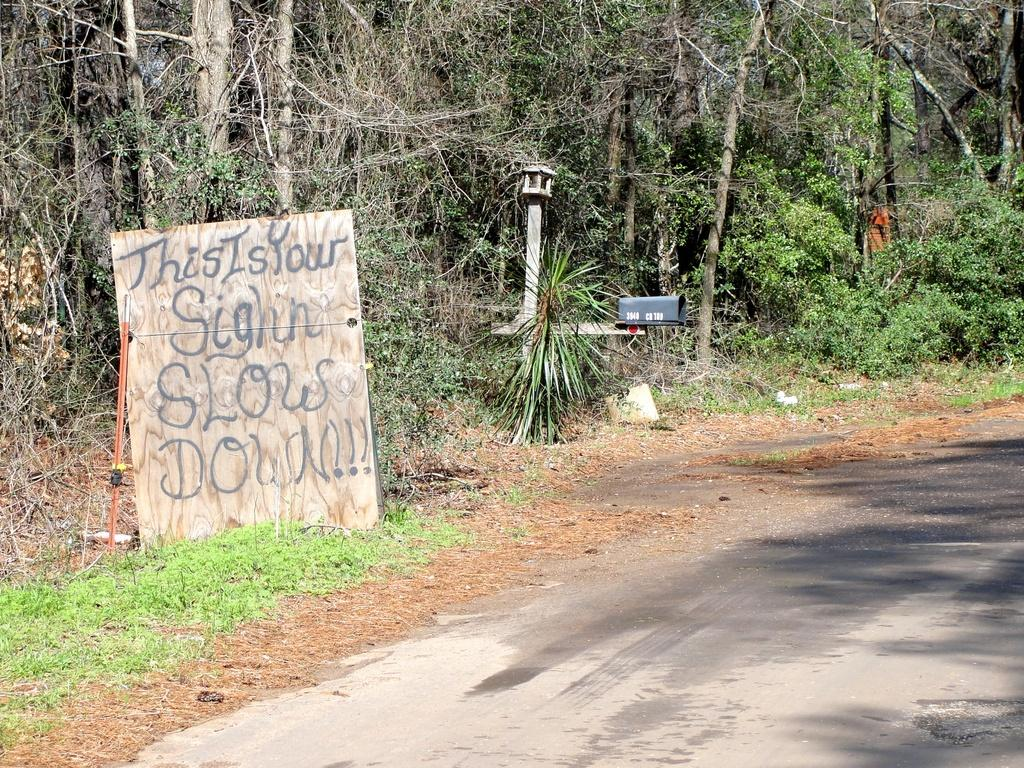What type of vegetation can be seen in the image? There are trees and plants in the image. What structures are present in the image? There are poles, boxes, a board, and a stick in the image. What type of ground surface is visible in the image? There is grass in the image, and a road is visible at the bottom. Are there any people in the image? Yes, there is a person standing in the image. What method of distribution is being used by the person in the image? There is no indication of any distribution method in the image, as the person is simply standing. What subject is the person teaching in the image? There is no indication of any teaching activity in the image, as the person is simply standing. 